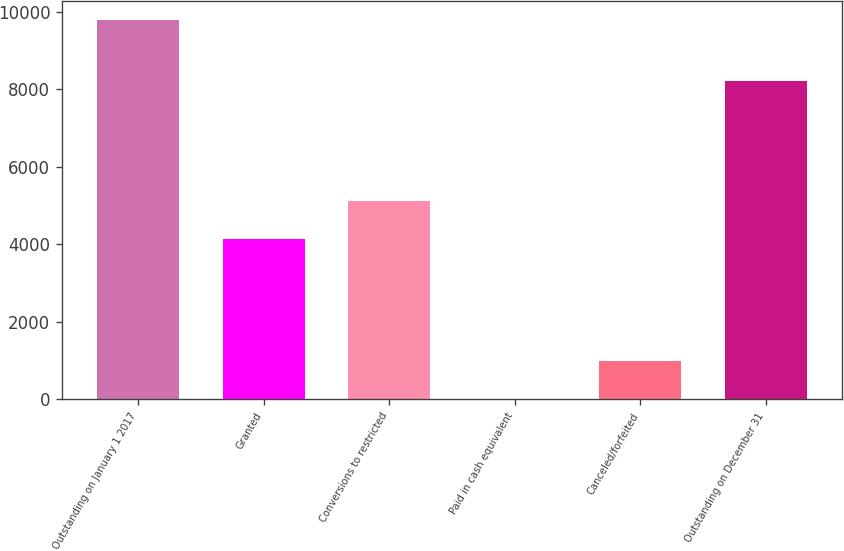Convert chart. <chart><loc_0><loc_0><loc_500><loc_500><bar_chart><fcel>Outstanding on January 1 2017<fcel>Granted<fcel>Conversions to restricted<fcel>Paid in cash equivalent<fcel>Canceled/forfeited<fcel>Outstanding on December 31<nl><fcel>9773<fcel>4133<fcel>5109.2<fcel>11<fcel>987.2<fcel>8212<nl></chart> 